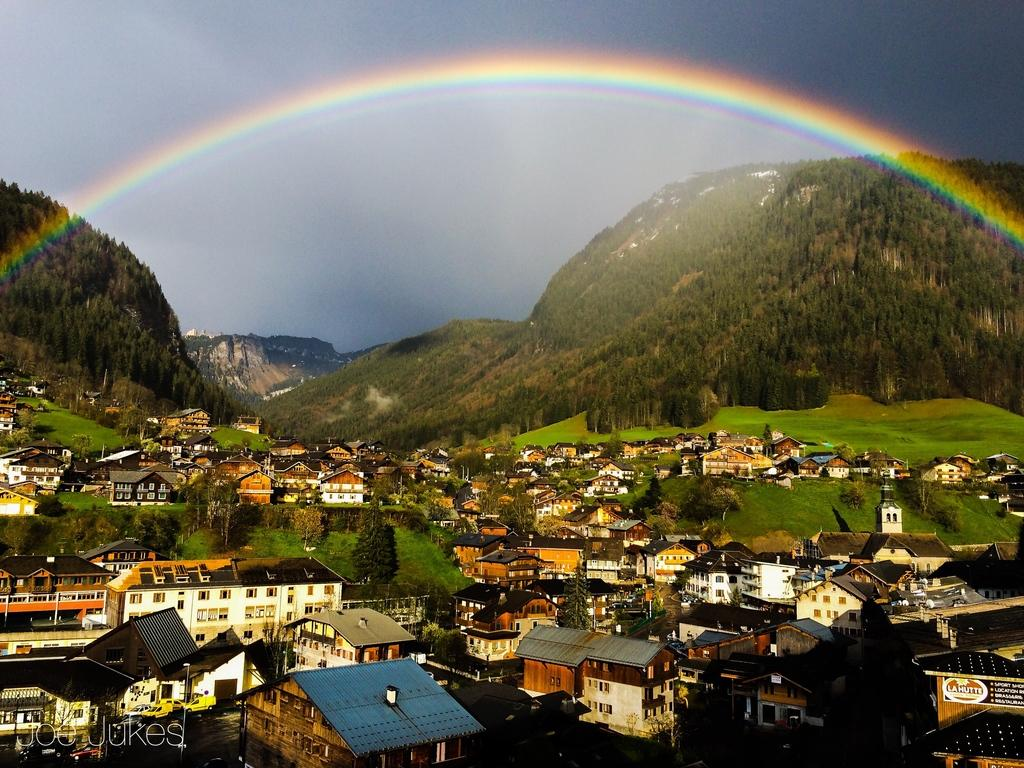What types of structures are located at the bottom of the image? There are houses at the bottom of the image. What other elements can be seen at the bottom of the image? There are trees and grass at the bottom of the image. What can be observed in the background of the image? There is a rainbow, hills, sky, and clouds in the background of the image. How many legs can be seen on the servant in the image? There is no servant present in the image. What type of bushes are growing near the houses in the image? There is no mention of bushes in the provided facts, and therefore we cannot answer this question. 